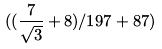Convert formula to latex. <formula><loc_0><loc_0><loc_500><loc_500>( ( \frac { 7 } { \sqrt { 3 } } + 8 ) / 1 9 7 + 8 7 )</formula> 